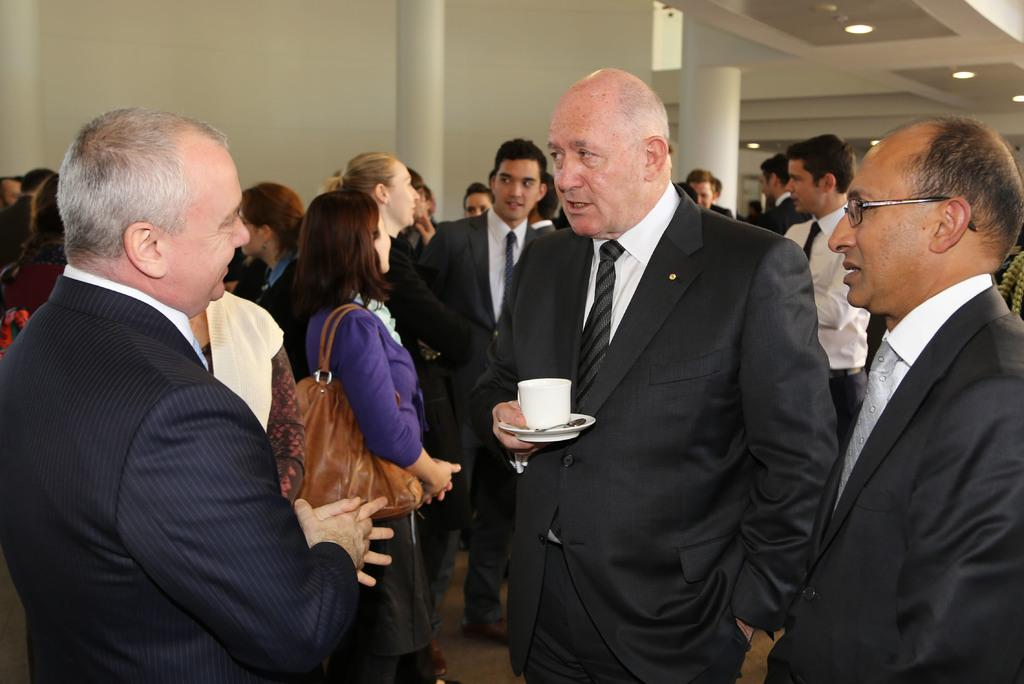What is happening in the image? There is a group of people standing in the image. What can be seen in the background of the image? There is a wall in the background of the image. What is visible at the top of the image? There are lights visible at the top of the image. What type of cork is being used to hold the lunch in the image? There is no cork or lunch present in the image. 